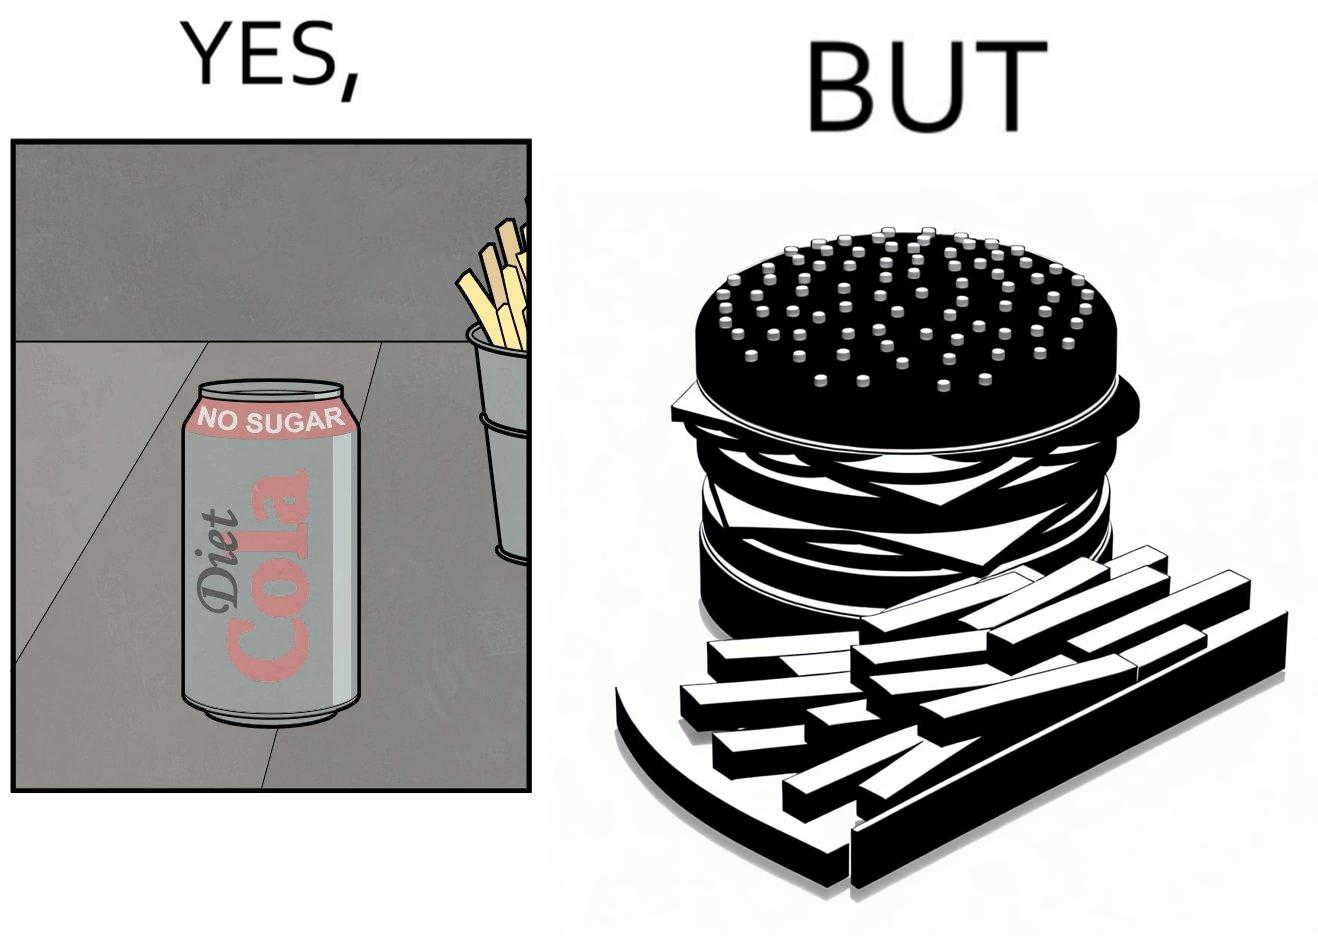Compare the left and right sides of this image. In the left part of the image: a cold drink can, named by diet cola, with french fries at the back In the right part of the image: a huge size burger with french fries 